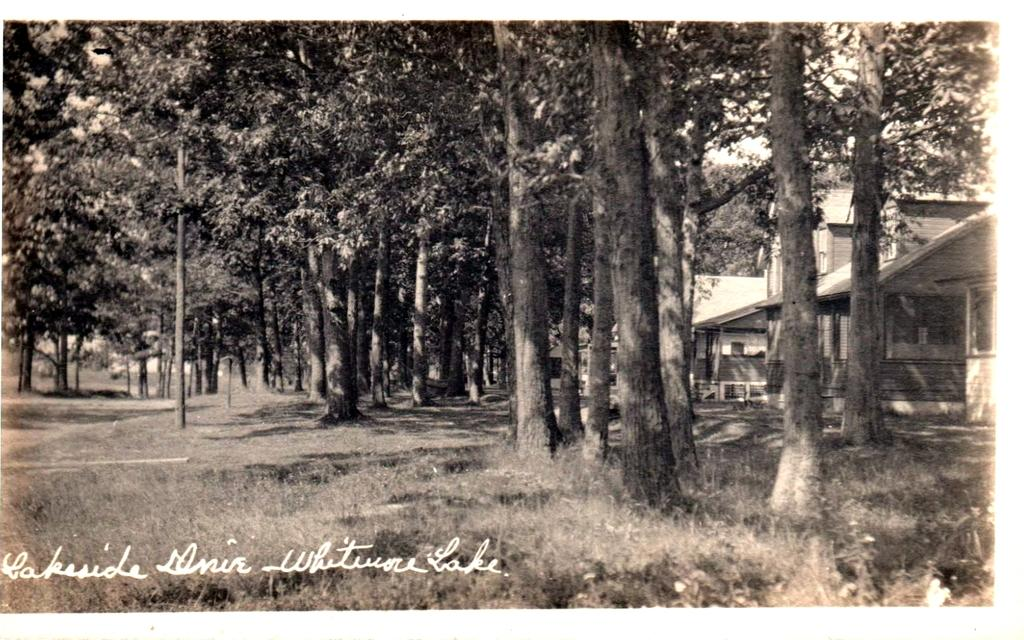What is the color scheme of the image? The image is black and white. What type of structures can be seen in the image? There are houses in the image. What type of vegetation is present in the image? There are trees in the image. What is visible in the background of the image? The sky is visible in the image. Can you describe the coat that the tree is wearing in the image? There is no coat present on the tree in the image, as trees do not wear clothing. 